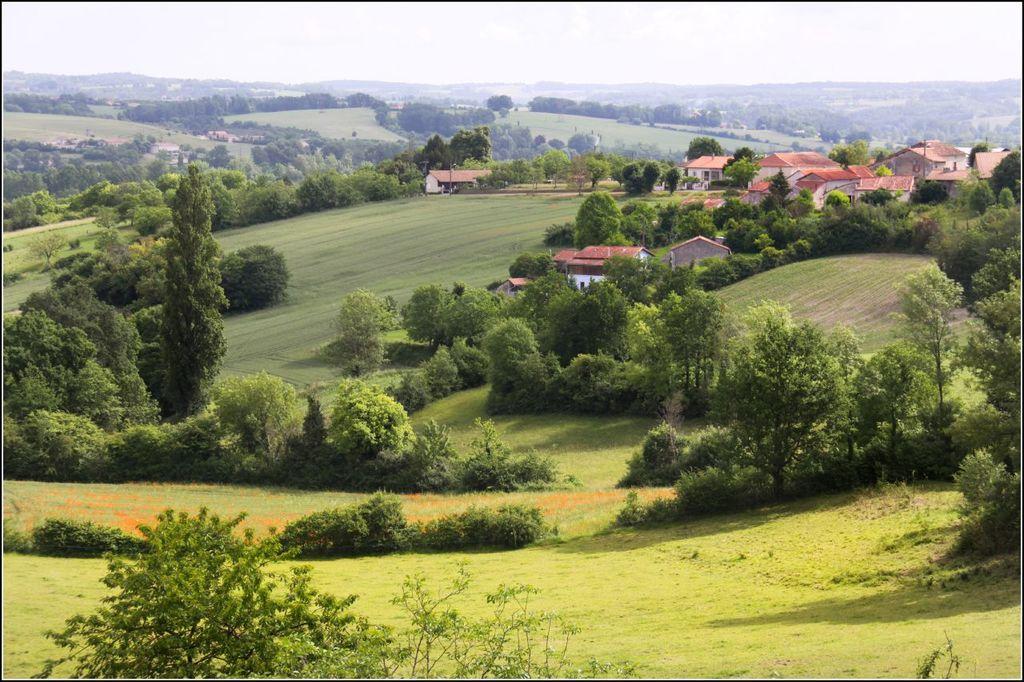In one or two sentences, can you explain what this image depicts? In this image we can see trees. On the ground there is grass. In the back there are buildings. In the background there is sky. 